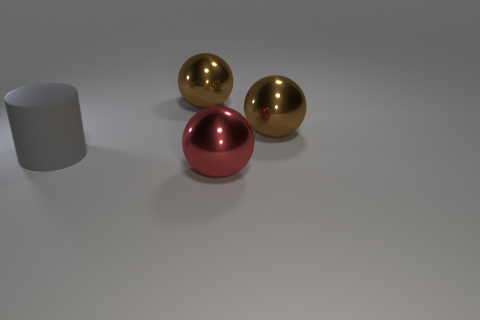There is a brown thing that is left of the object that is in front of the big gray matte thing; what number of gray cylinders are behind it? 0 